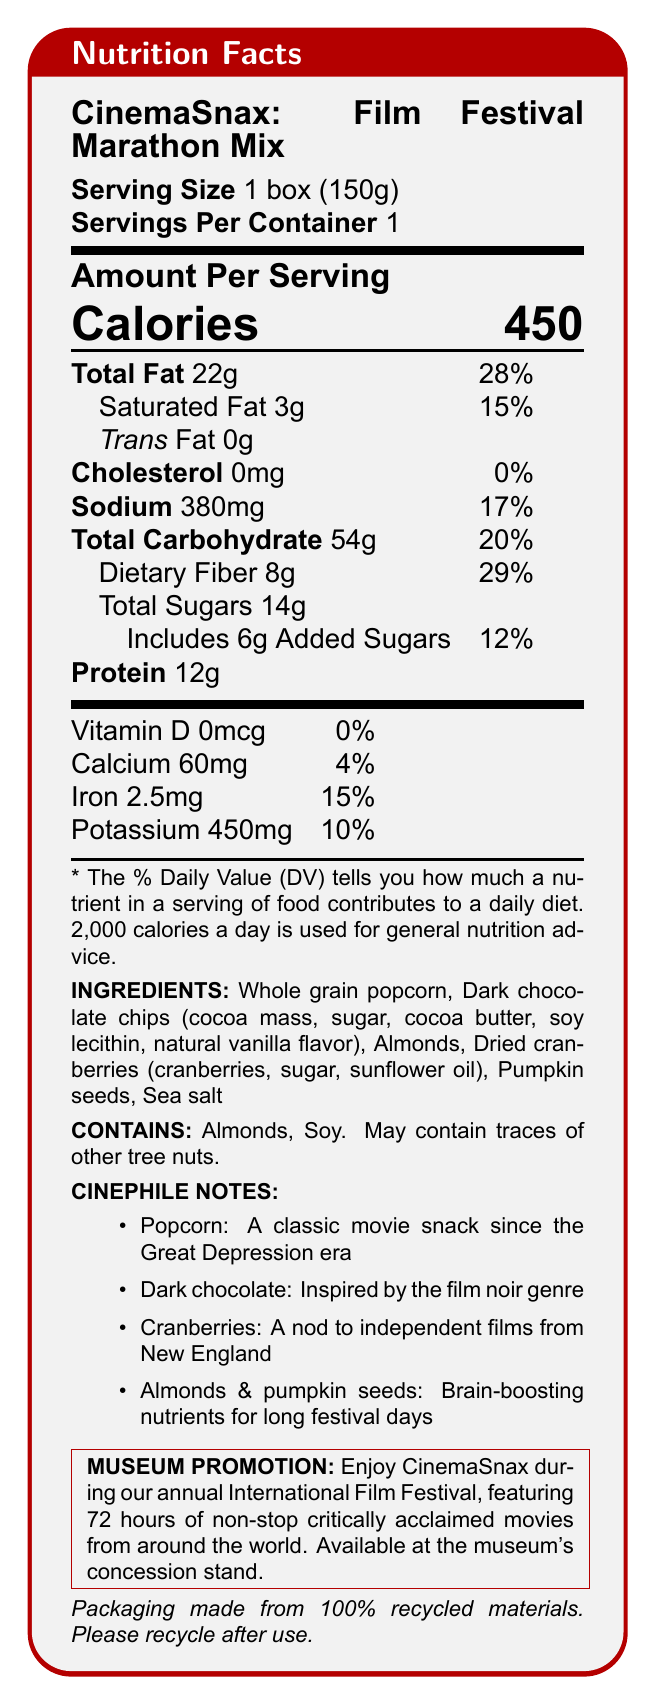what is the serving size? The document lists the serving size as "1 box (150g)" under the "Serving Size" heading.
Answer: 1 box (150g) how many calories are in each serving? The document specifies "Calories 450" in large font under the "Amount Per Serving" section.
Answer: 450 what is the daily value percentage of total fat per serving? The document lists "Total Fat 22g" followed by "28%" under the "Amount Per Serving" section.
Answer: 28% how much dietary fiber does the CinemaSnax provide? The document includes "Dietary Fiber 8g" under the "Total Carbohydrate" section in the "Amount Per Serving" information.
Answer: 8g which vitamin does the CinemaSnax not contain? The document shows "Vitamin D 0mcg" with a daily value of "0%" under the vitamin and mineral section.
Answer: Vitamin D is this snack suitable for someone with a soy allergy? The "CONTAINS" section clearly states that the product contains soy, making it unsuitable for someone with a soy allergy.
Answer: No what are the main ingredients in CinemaSnax? The "INGREDIENTS" section lists all the main ingredients.
Answer: Whole grain popcorn, Dark chocolate chips, Almonds, Dried cranberries, Pumpkin seeds, Sea salt what is the percentage of daily value for sodium? The document indicates "Sodium 380mg" with a daily value of "17%" under the "Amount Per Serving" section.
Answer: 17% which cinephile note references New England? The "CINEPHILE NOTES" section mentions cranberries as "A nod to independent films from New England."
Answer: Cranberries which type of packaging materials are used for CinemaSnax? The document states that the packaging is made from "100% recycled materials" under the sustainability note.
Answer: 100% recycled materials how much protein does one serving provide? The document lists "Protein 12g" under the "Amount Per Serving" section.
Answer: 12g which allergen does this product contain? A. Peanuts B. Tree Nuts C. Gluten The "CONTAINS" section specifies that the product contains almonds, which are a type of tree nut.
Answer: B how much added sugar is included in the snack? The document notes "Includes 6g Added Sugars" under the "Total Sugars" section in the "Amount Per Serving" information.
Answer: 6g what is the film genre inspiration for the dark chocolate ingredient? A. Comedy B. Horror C. Film Noir The "CINEPHILE NOTES" section indicates that dark chocolate is "Inspired by the film noir genre."
Answer: C which nutrient has the highest daily value percentage? A. Total Fat B. Dietary Fiber C. Iron The daily value percentage for dietary fiber is 29%, which is higher than that of total fat (28%) and iron (15%).
Answer: B does CinemaSnax contain any cholesterol? The "Amount Per Serving" section lists "Cholesterol 0mg" with a daily value of "0%".
Answer: No does this product help with brain-boosting nutrients for long festival days? The "CINEPHILE NOTES" section mentions that almonds and pumpkin seeds are brain-boosting nutrients for long festival days.
Answer: Yes describe the main features and purpose of the CinemaSnax product. The document describes the CinemaSnax product as a curated snack mix for film festival marathons, showcasing its health benefits, ingredient list, cinephile-related notes, sustainability efforts, and museum promotion.
Answer: The CinemaSnax product is a healthy snack box designed for a film festival marathon. It contains whole grain popcorn, dark chocolate chips, almonds, dried cranberries, pumpkin seeds, and sea salt. The snack is high in fiber, a good source of protein, and free from artificial colors or flavors. It includes cinephile notes that relate the ingredients to different elements of film culture. The packaging is made from 100% recycled materials, promoting sustainability. The product is available during the museum's annual International Film Festival. what are the specific health benefits mentioned for CinemaSnax? The document provides detailed nutrition information and special features, but it does not specify all the specific health benefits.
Answer: Cannot be determined 